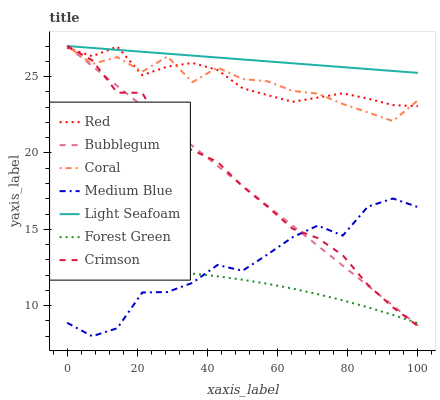Does Forest Green have the minimum area under the curve?
Answer yes or no. Yes. Does Light Seafoam have the maximum area under the curve?
Answer yes or no. Yes. Does Medium Blue have the minimum area under the curve?
Answer yes or no. No. Does Medium Blue have the maximum area under the curve?
Answer yes or no. No. Is Light Seafoam the smoothest?
Answer yes or no. Yes. Is Medium Blue the roughest?
Answer yes or no. Yes. Is Bubblegum the smoothest?
Answer yes or no. No. Is Bubblegum the roughest?
Answer yes or no. No. Does Medium Blue have the lowest value?
Answer yes or no. Yes. Does Bubblegum have the lowest value?
Answer yes or no. No. Does Light Seafoam have the highest value?
Answer yes or no. Yes. Does Medium Blue have the highest value?
Answer yes or no. No. Is Medium Blue less than Coral?
Answer yes or no. Yes. Is Red greater than Medium Blue?
Answer yes or no. Yes. Does Red intersect Light Seafoam?
Answer yes or no. Yes. Is Red less than Light Seafoam?
Answer yes or no. No. Is Red greater than Light Seafoam?
Answer yes or no. No. Does Medium Blue intersect Coral?
Answer yes or no. No. 